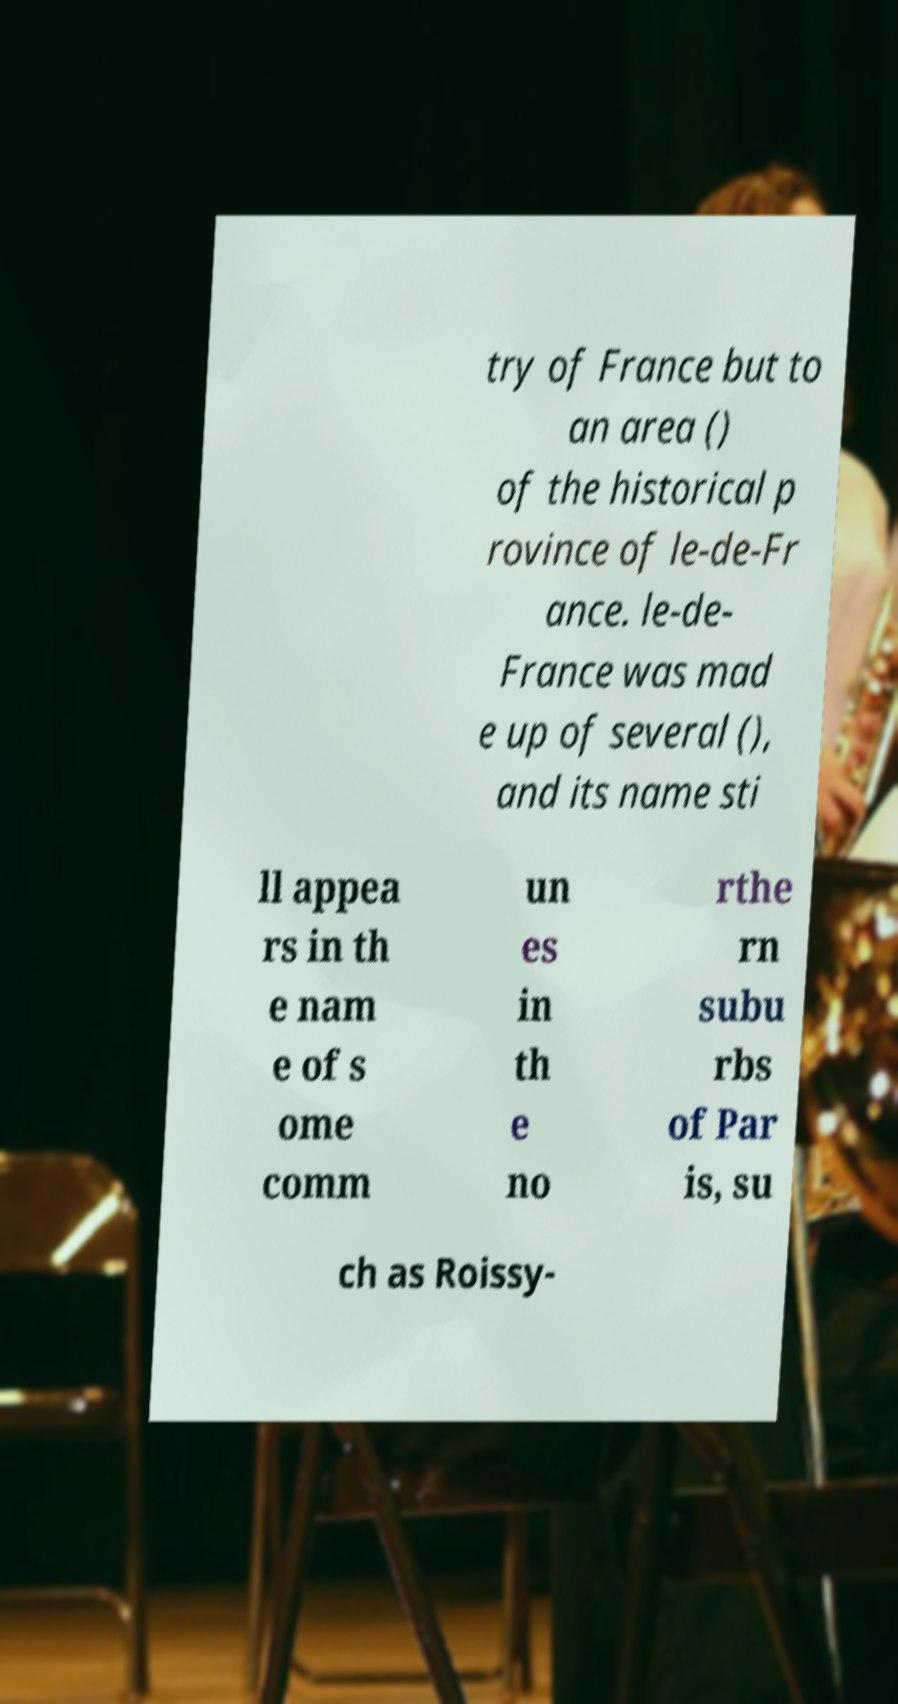For documentation purposes, I need the text within this image transcribed. Could you provide that? try of France but to an area () of the historical p rovince of le-de-Fr ance. le-de- France was mad e up of several (), and its name sti ll appea rs in th e nam e of s ome comm un es in th e no rthe rn subu rbs of Par is, su ch as Roissy- 